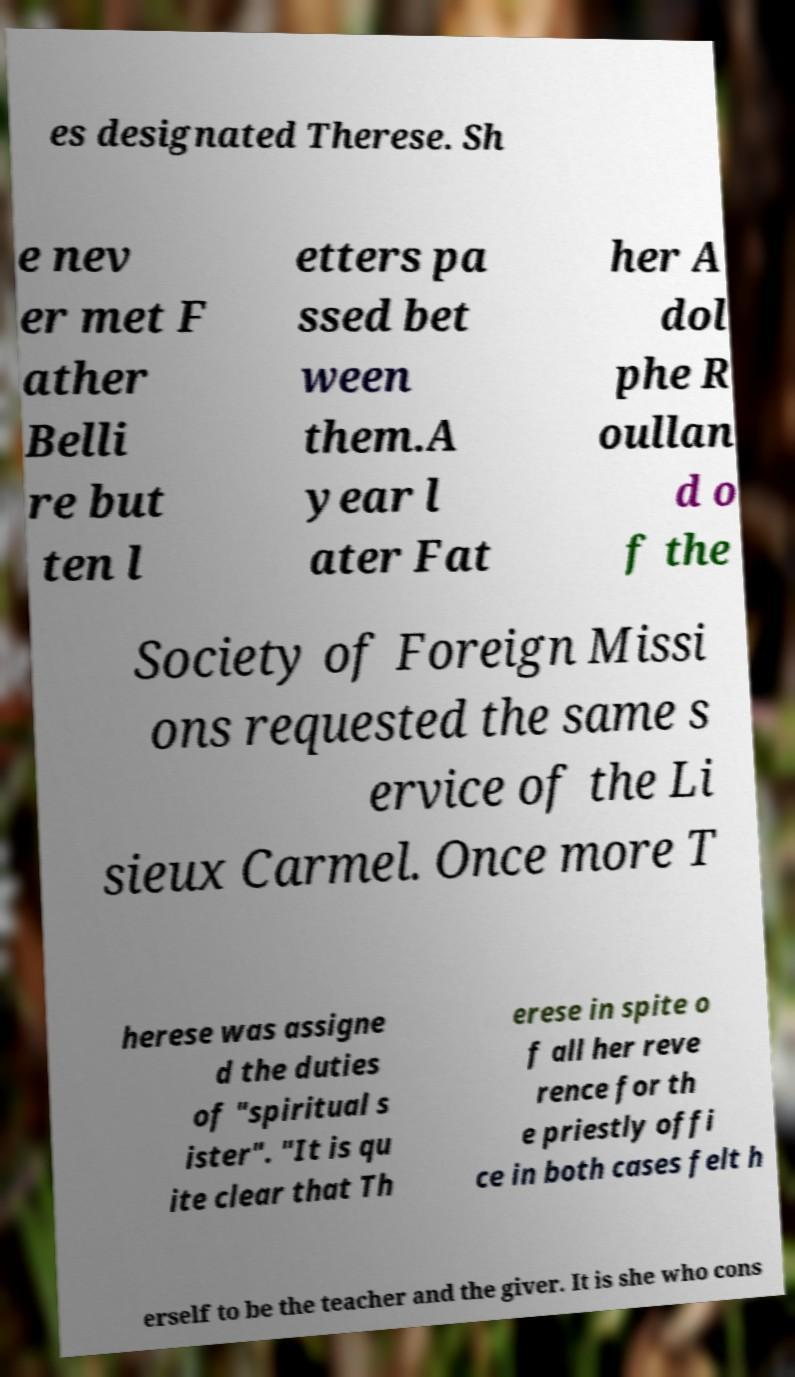Can you accurately transcribe the text from the provided image for me? es designated Therese. Sh e nev er met F ather Belli re but ten l etters pa ssed bet ween them.A year l ater Fat her A dol phe R oullan d o f the Society of Foreign Missi ons requested the same s ervice of the Li sieux Carmel. Once more T herese was assigne d the duties of "spiritual s ister". "It is qu ite clear that Th erese in spite o f all her reve rence for th e priestly offi ce in both cases felt h erself to be the teacher and the giver. It is she who cons 